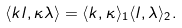Convert formula to latex. <formula><loc_0><loc_0><loc_500><loc_500>\langle k l , \kappa \lambda \rangle = \langle k , \kappa \rangle _ { 1 } \langle l , \lambda \rangle _ { 2 } .</formula> 